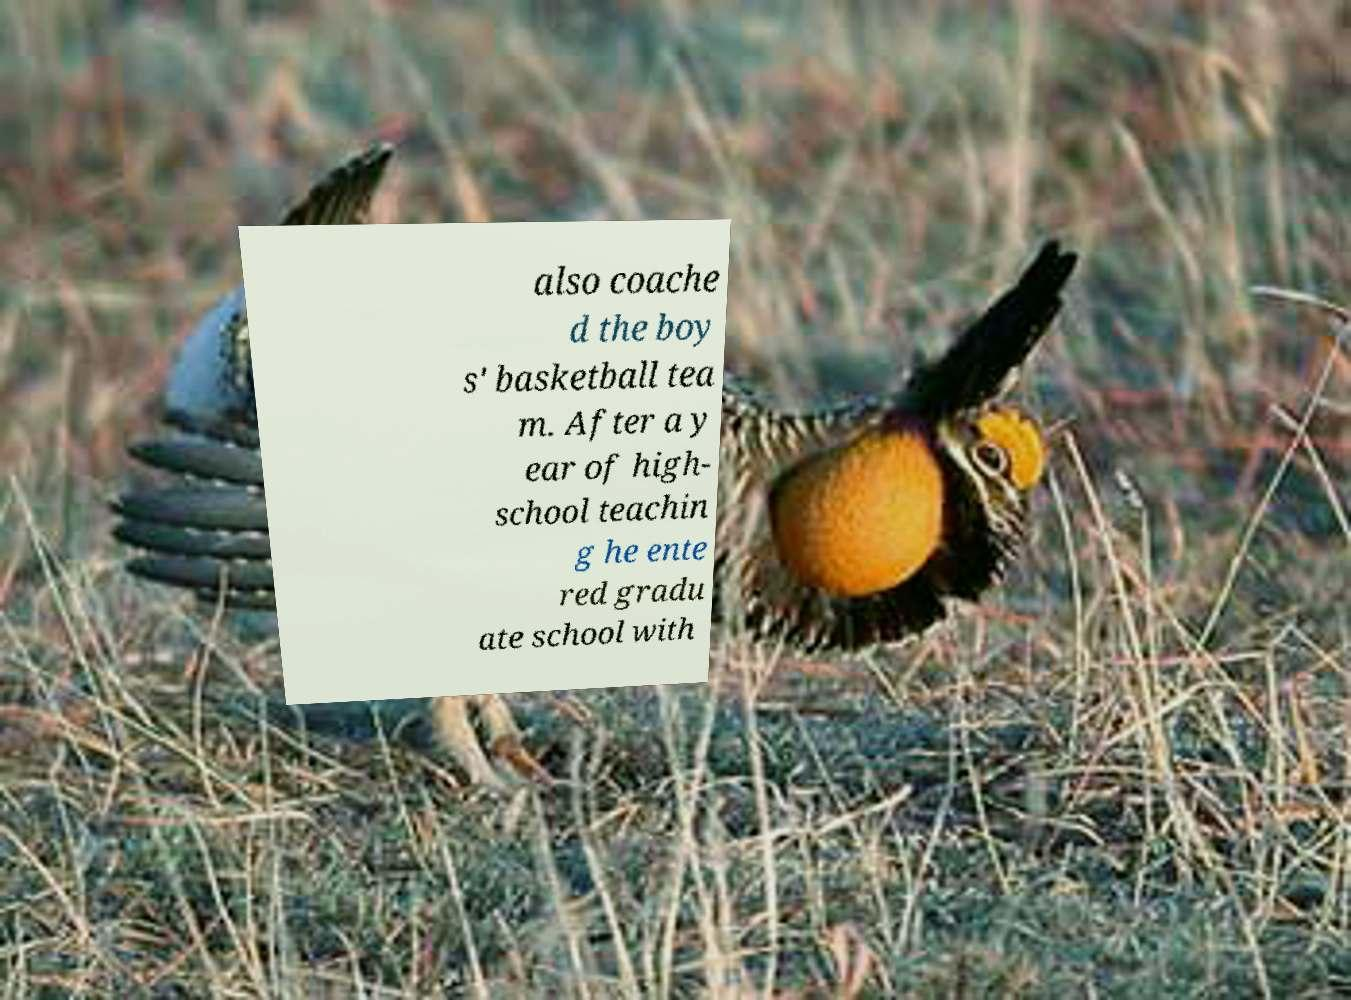Can you read and provide the text displayed in the image?This photo seems to have some interesting text. Can you extract and type it out for me? also coache d the boy s' basketball tea m. After a y ear of high- school teachin g he ente red gradu ate school with 